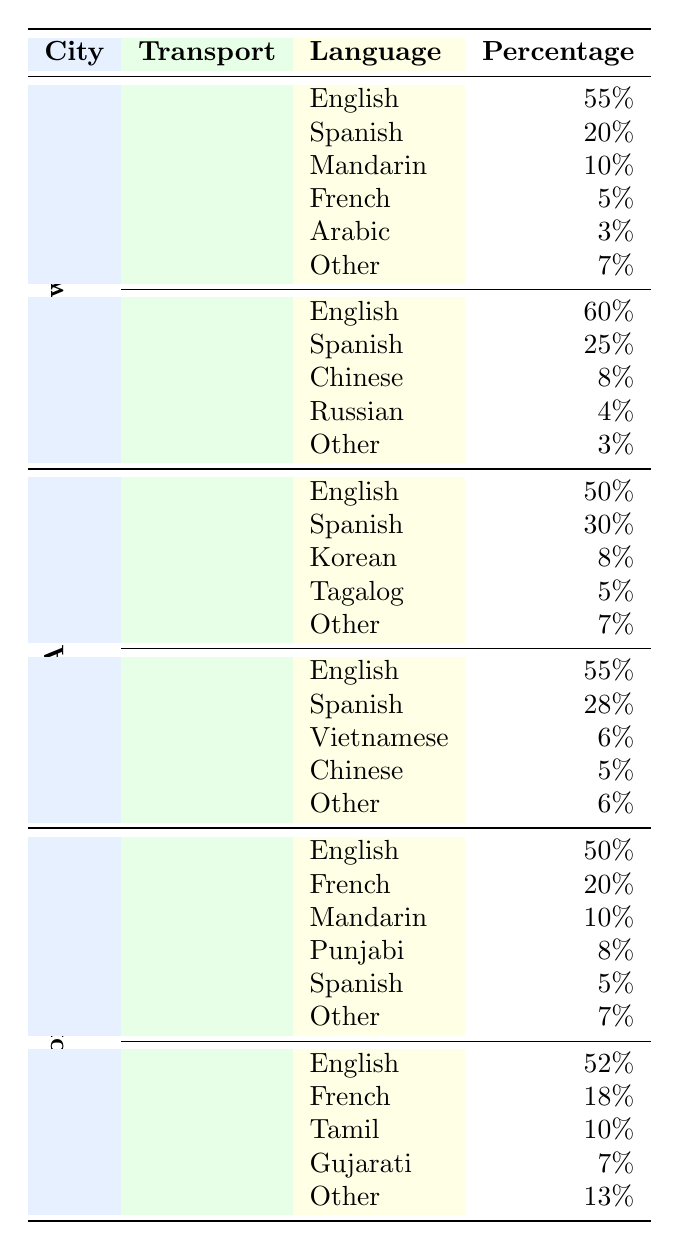What percentage of language use in the New York Subway is represented by Spanish? In the New York Subway, Spanish is listed under Languages Spoken with a Percentage of 20%.
Answer: 20% What is the predominant language spoken on Los Angeles Buses? The predominant language is English at 55%.
Answer: English Which city has the highest percentage of Spanish speakers on public transportation? In New York, Spanish speakers represent 25% on Buses and 20% on Subway. In Los Angeles, it is 28% on Buses and 30% on Metro. In Toronto, it's 5% on Subway and the percentage is not detailed for Streetcars. The highest percentage is found in Los Angeles on Metro at 30%.
Answer: Los Angeles What is the total percentage of English speakers across all transport modes in Toronto? The percentage of English speakers is 50% in Subway and 52% in Streetcars. Adding these percentages gives us 50% + 52% = 102%.
Answer: 102% Is Arabic spoken in public transportation in Los Angeles? No, there is no mention of Arabic among the languages spoken on either Metro or Buses in Los Angeles.
Answer: No Which mode of transport in New York has the highest percentage of English speakers? Looking at the New York data, the Buses have 60% English speakers, while the Subway has 55%. Therefore, Buses have the highest percentage of English speakers.
Answer: Buses What percentage of languages spoken on Toronto Subway is accounted for by French? French accounts for 20% in Toronto Subway.
Answer: 20% Which language is shared by both the New York Subway and the Los Angeles Metro? Both the New York Subway and the Los Angeles Metro feature Mandarin as a language spoken, with percentages of 10% in New York and 0% in Los Angeles.
Answer: Mandarin What is the difference in the percentage of Mandarin speakers between New York and Toronto Subways? In New York, Mandarin is 10%, and in Toronto, it is also 10%. The difference is 10% - 10% = 0%.
Answer: 0% 